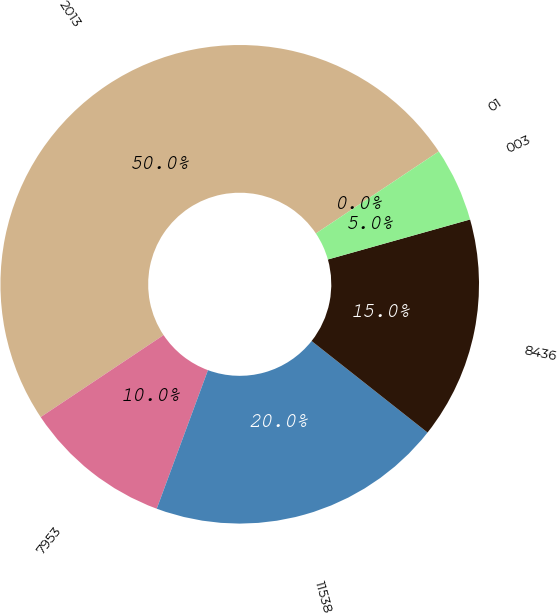<chart> <loc_0><loc_0><loc_500><loc_500><pie_chart><fcel>2013<fcel>7953<fcel>11538<fcel>8436<fcel>003<fcel>01<nl><fcel>50.0%<fcel>10.0%<fcel>20.0%<fcel>15.0%<fcel>5.0%<fcel>0.0%<nl></chart> 